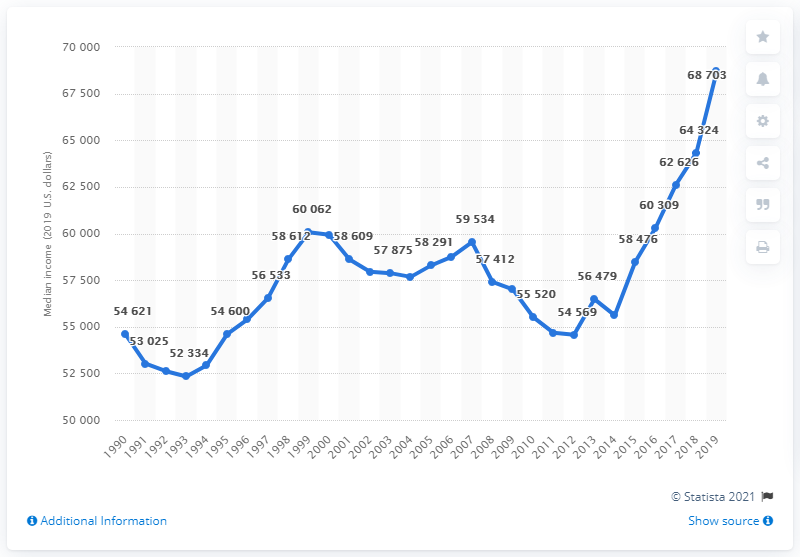Specify some key components in this picture. According to data released in 2019, the median household income in the United States was 68,703. In the years 2018-2019, the average household income was 66,513.5. 